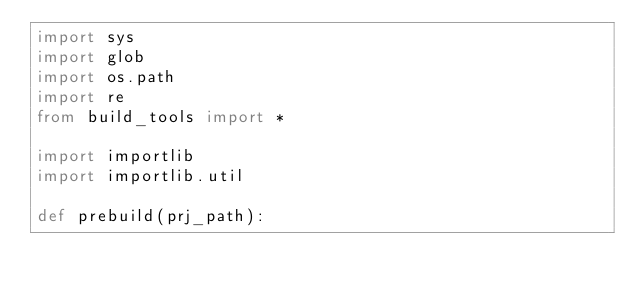Convert code to text. <code><loc_0><loc_0><loc_500><loc_500><_Python_>import sys
import glob  
import os.path 
import re
from build_tools import *

import importlib
import importlib.util

def prebuild(prj_path):</code> 